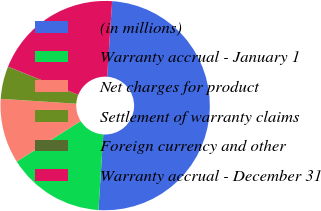<chart> <loc_0><loc_0><loc_500><loc_500><pie_chart><fcel>(in millions)<fcel>Warranty accrual - January 1<fcel>Net charges for product<fcel>Settlement of warranty claims<fcel>Foreign currency and other<fcel>Warranty accrual - December 31<nl><fcel>49.95%<fcel>15.0%<fcel>10.01%<fcel>5.02%<fcel>0.02%<fcel>20.0%<nl></chart> 